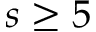Convert formula to latex. <formula><loc_0><loc_0><loc_500><loc_500>s \geq 5</formula> 